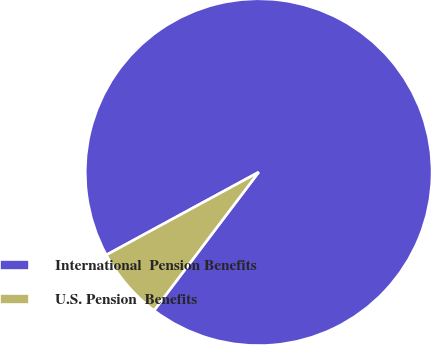Convert chart to OTSL. <chart><loc_0><loc_0><loc_500><loc_500><pie_chart><fcel>International  Pension Benefits<fcel>U.S. Pension  Benefits<nl><fcel>93.23%<fcel>6.77%<nl></chart> 